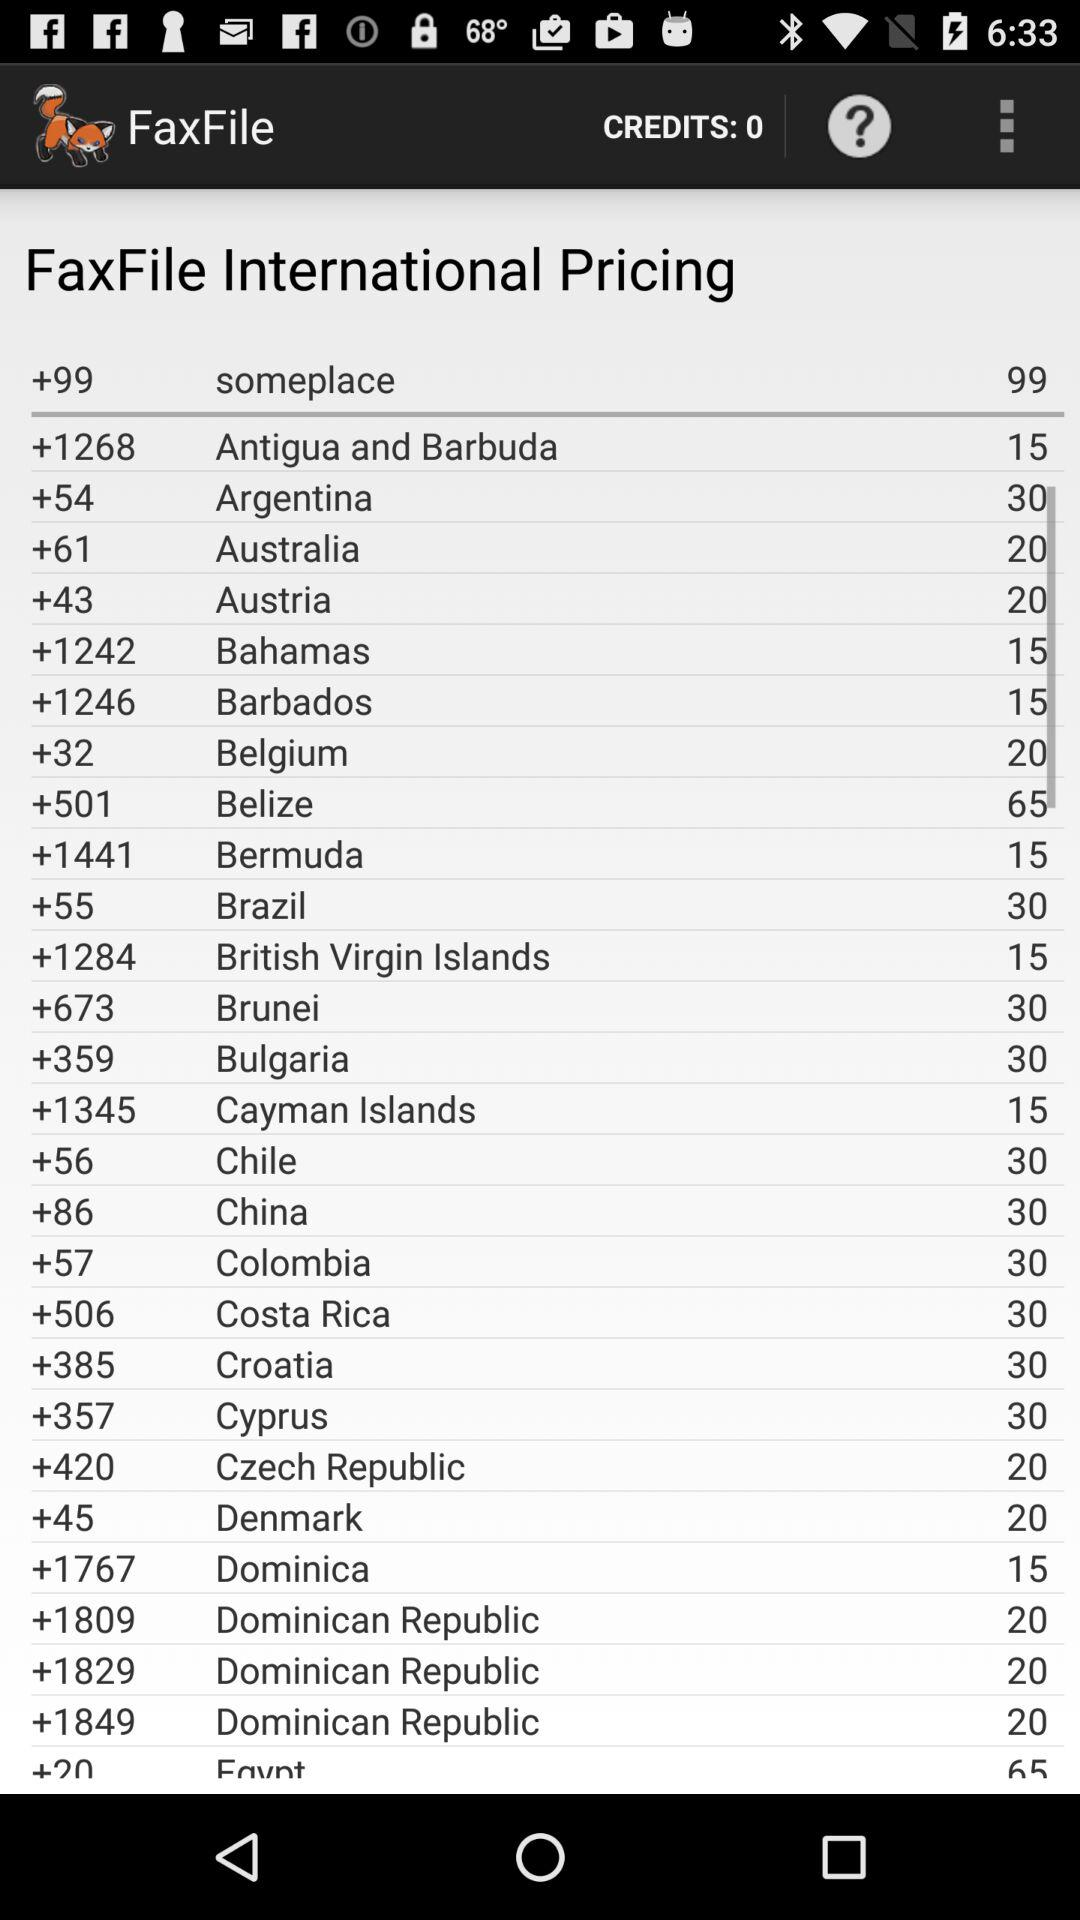What's the dial code of France?
When the provided information is insufficient, respond with <no answer>. <no answer> 